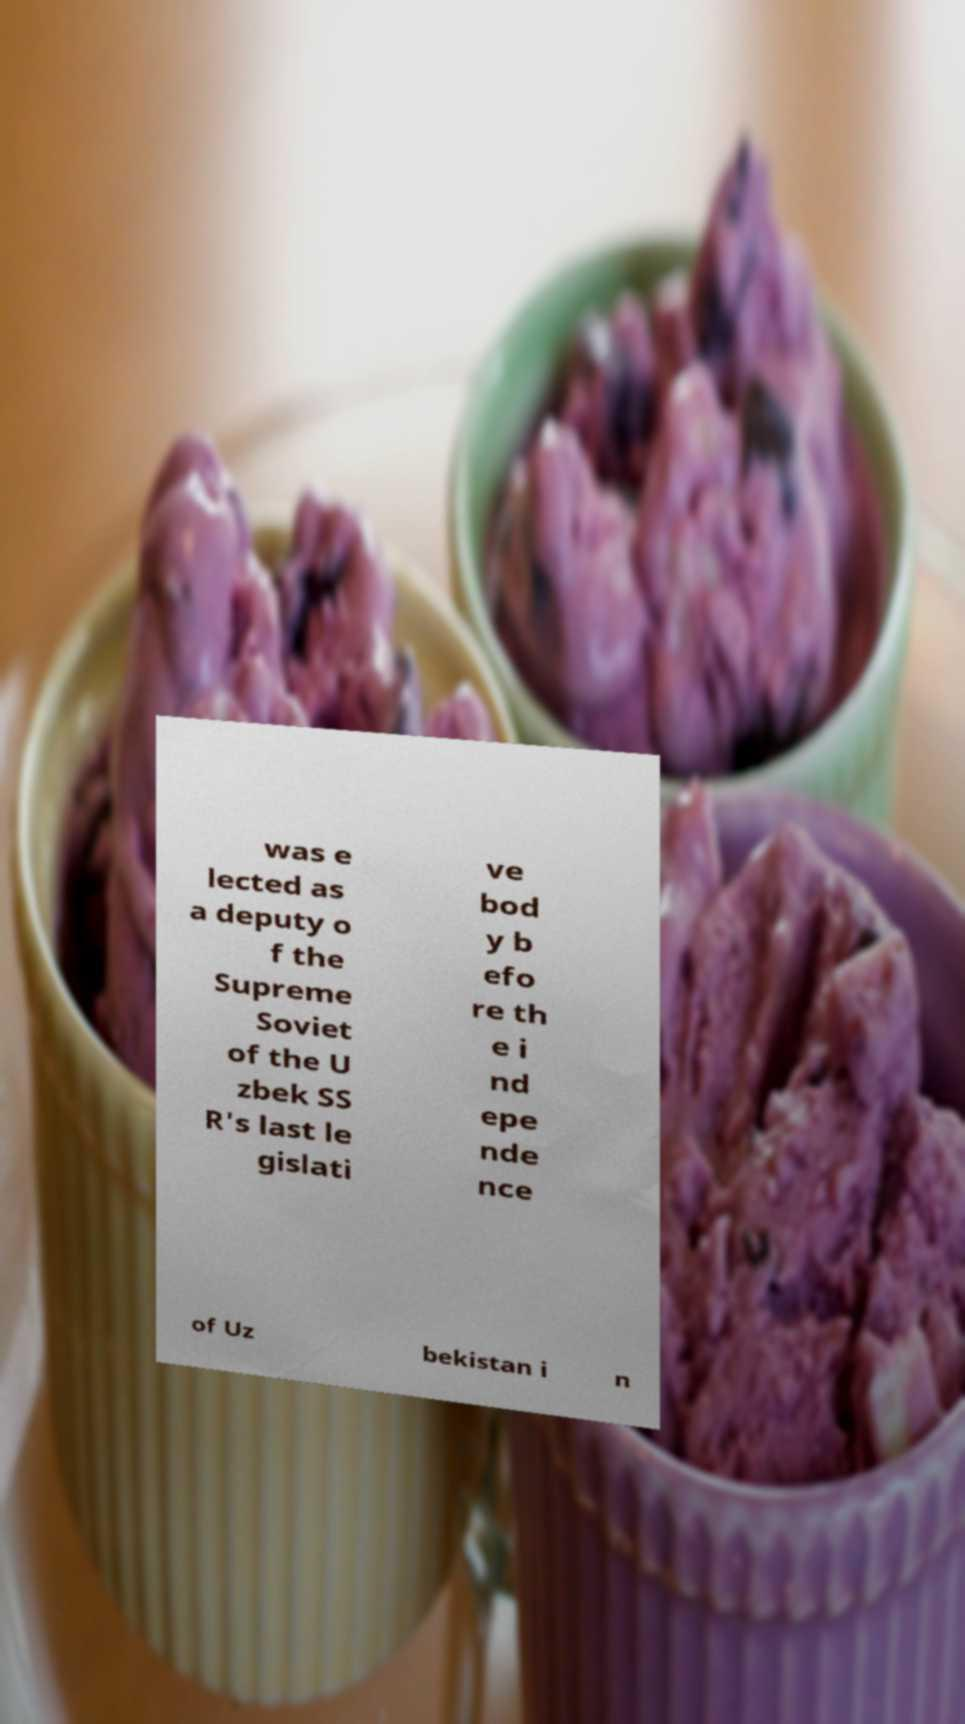I need the written content from this picture converted into text. Can you do that? was e lected as a deputy o f the Supreme Soviet of the U zbek SS R's last le gislati ve bod y b efo re th e i nd epe nde nce of Uz bekistan i n 